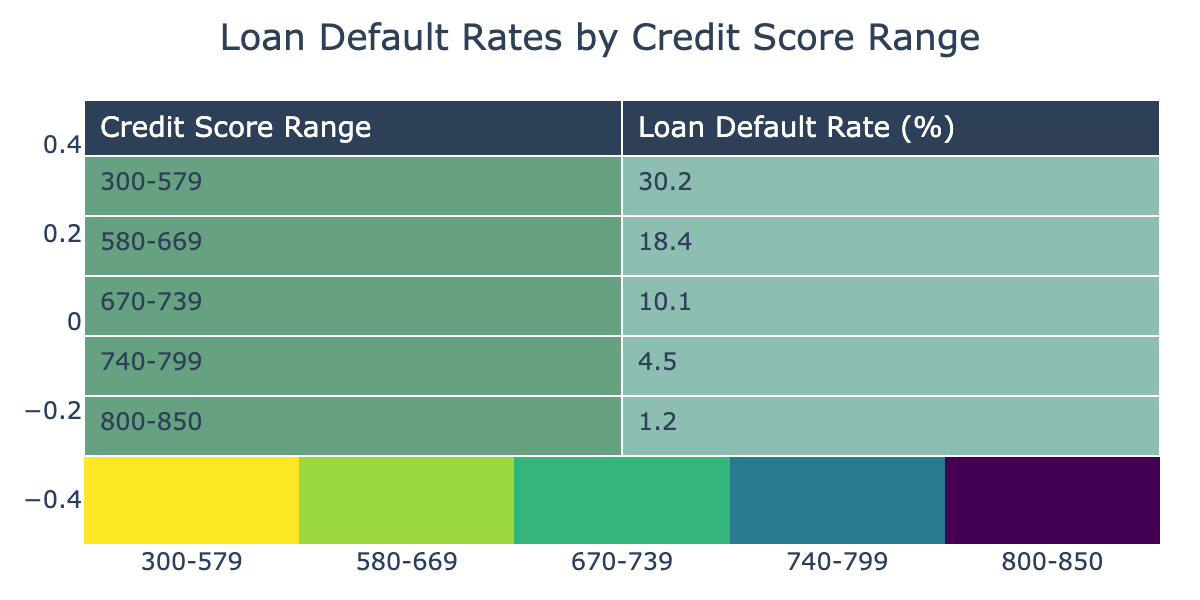What is the loan default rate for the credit score range of 300-579? From the table, the loan default rate for the credit score range of 300-579 is explicitly listed as 30.2%.
Answer: 30.2% What is the loan default rate for the highest credit score range of 800-850? The table states that the loan default rate for the credit score range of 800-850 is 1.2%.
Answer: 1.2% Is the loan default rate for the 670-739 credit score range lower than the rate for the 580-669 range? The loan default rate for the 670-739 range is 10.1%, which is lower than the rate for the 580-669 range of 18.4%.
Answer: Yes What is the difference in loan default rates between the 740-799 and the 300-579 credit score ranges? The loan default rate for the 740-799 range is 4.5%, and for the 300-579 range, it's 30.2%. The difference is 30.2% - 4.5% = 25.7%.
Answer: 25.7% What percentage of loan defaults can be expected for credit scores 580-669 and 670-739 combined? The loan default rates are 18.4% for 580-669 and 10.1% for 670-739. The sum is 18.4% + 10.1% = 28.5%.
Answer: 28.5% Which credit score range has the highest loan default rate? By examining the table, it is clear that the 300-579 range has the highest loan default rate at 30.2%.
Answer: 300-579 Are the loan default rates generally decreasing as credit scores increase? Yes, as seen in the table, the loan default rates decrease as the credit score ranges move from lower to higher scores.
Answer: Yes Calculate the average loan default rate of the two lowest credit score ranges combined. The rates for the 300-579 range (30.2%) and the 580-669 range (18.4%) need to be averaged. The sum is 30.2% + 18.4% = 48.6% and dividing by 2 gives an average of 24.3%.
Answer: 24.3% What is the loan default rate for credit scores of 740 or higher? The credit score ranges of 740-799 and 800-850 have default rates of 4.5% and 1.2%, respectively. Therefore, adding these gives 4.5% + 1.2% = 5.7%.
Answer: 5.7% 